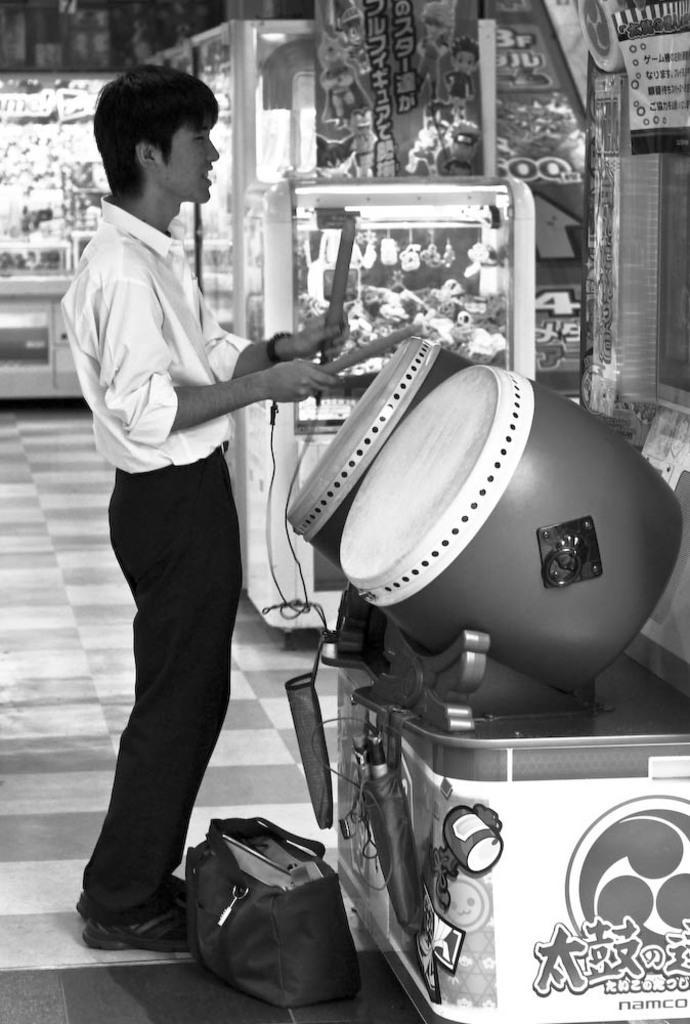Could you give a brief overview of what you see in this image? It is a black and white picture. In the front of the image I can see a person is holding sticks. On the table there are musical drums. Near that person there is a bag and objects. In the background there are glass cupboards, posters, check floor and objects. 